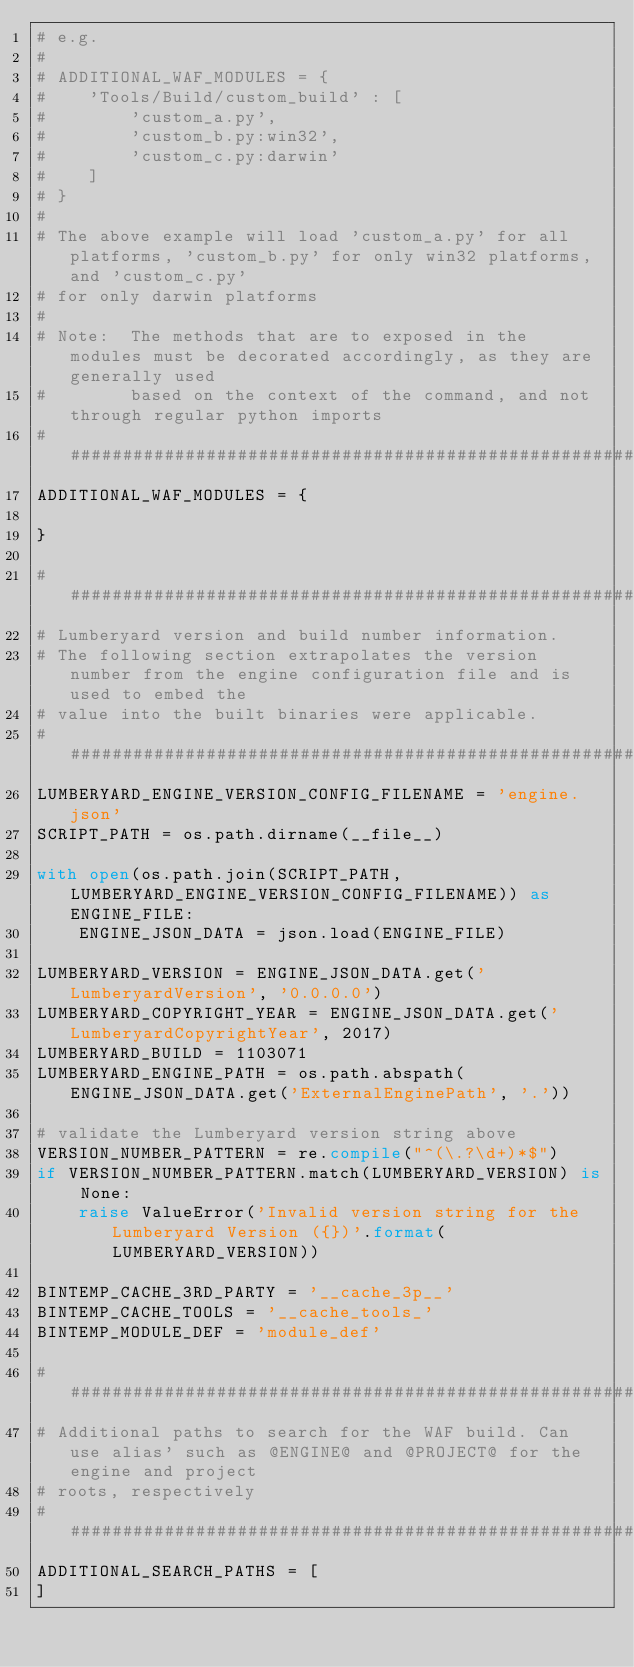Convert code to text. <code><loc_0><loc_0><loc_500><loc_500><_Python_># e.g.
#
# ADDITIONAL_WAF_MODULES = {
#    'Tools/Build/custom_build' : [
#        'custom_a.py',
#        'custom_b.py:win32',
#        'custom_c.py:darwin'
#    ]
# }
#
# The above example will load 'custom_a.py' for all platforms, 'custom_b.py' for only win32 platforms, and 'custom_c.py'
# for only darwin platforms
#
# Note:  The methods that are to exposed in the modules must be decorated accordingly, as they are generally used
#        based on the context of the command, and not through regular python imports
########################################################################################################################
ADDITIONAL_WAF_MODULES = {

}

########################################################################################################################
# Lumberyard version and build number information.
# The following section extrapolates the version number from the engine configuration file and is used to embed the
# value into the built binaries were applicable.
########################################################################################################################
LUMBERYARD_ENGINE_VERSION_CONFIG_FILENAME = 'engine.json'
SCRIPT_PATH = os.path.dirname(__file__)

with open(os.path.join(SCRIPT_PATH, LUMBERYARD_ENGINE_VERSION_CONFIG_FILENAME)) as ENGINE_FILE:
    ENGINE_JSON_DATA = json.load(ENGINE_FILE)

LUMBERYARD_VERSION = ENGINE_JSON_DATA.get('LumberyardVersion', '0.0.0.0')
LUMBERYARD_COPYRIGHT_YEAR = ENGINE_JSON_DATA.get('LumberyardCopyrightYear', 2017)
LUMBERYARD_BUILD = 1103071
LUMBERYARD_ENGINE_PATH = os.path.abspath(ENGINE_JSON_DATA.get('ExternalEnginePath', '.'))

# validate the Lumberyard version string above
VERSION_NUMBER_PATTERN = re.compile("^(\.?\d+)*$")
if VERSION_NUMBER_PATTERN.match(LUMBERYARD_VERSION) is None:
    raise ValueError('Invalid version string for the Lumberyard Version ({})'.format(LUMBERYARD_VERSION))

BINTEMP_CACHE_3RD_PARTY = '__cache_3p__'
BINTEMP_CACHE_TOOLS = '__cache_tools_'
BINTEMP_MODULE_DEF = 'module_def'

########################################################################################################################
# Additional paths to search for the WAF build. Can use alias' such as @ENGINE@ and @PROJECT@ for the engine and project
# roots, respectively
########################################################################################################################
ADDITIONAL_SEARCH_PATHS = [
]
</code> 